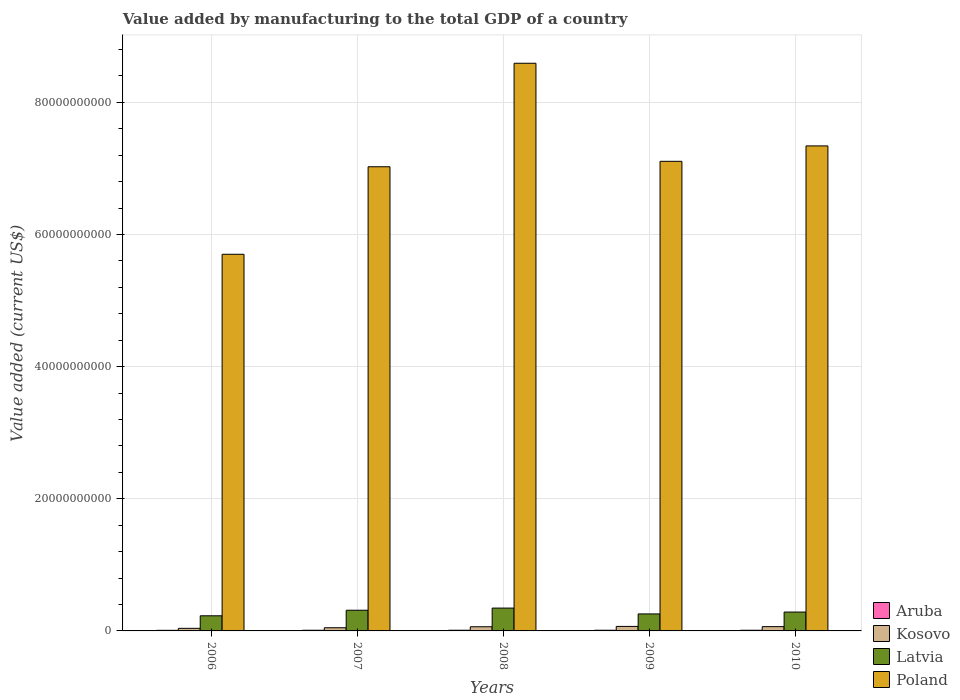How many different coloured bars are there?
Offer a very short reply. 4. How many groups of bars are there?
Offer a terse response. 5. Are the number of bars per tick equal to the number of legend labels?
Offer a very short reply. Yes. Are the number of bars on each tick of the X-axis equal?
Give a very brief answer. Yes. What is the label of the 3rd group of bars from the left?
Give a very brief answer. 2008. In how many cases, is the number of bars for a given year not equal to the number of legend labels?
Provide a short and direct response. 0. What is the value added by manufacturing to the total GDP in Latvia in 2010?
Give a very brief answer. 2.86e+09. Across all years, what is the maximum value added by manufacturing to the total GDP in Kosovo?
Give a very brief answer. 6.82e+08. Across all years, what is the minimum value added by manufacturing to the total GDP in Poland?
Ensure brevity in your answer.  5.70e+1. What is the total value added by manufacturing to the total GDP in Latvia in the graph?
Ensure brevity in your answer.  1.43e+1. What is the difference between the value added by manufacturing to the total GDP in Kosovo in 2009 and that in 2010?
Your response must be concise. 3.44e+07. What is the difference between the value added by manufacturing to the total GDP in Latvia in 2010 and the value added by manufacturing to the total GDP in Aruba in 2006?
Provide a succinct answer. 2.76e+09. What is the average value added by manufacturing to the total GDP in Aruba per year?
Your response must be concise. 9.95e+07. In the year 2008, what is the difference between the value added by manufacturing to the total GDP in Poland and value added by manufacturing to the total GDP in Latvia?
Your answer should be compact. 8.25e+1. What is the ratio of the value added by manufacturing to the total GDP in Aruba in 2009 to that in 2010?
Provide a short and direct response. 1.01. Is the value added by manufacturing to the total GDP in Poland in 2009 less than that in 2010?
Keep it short and to the point. Yes. Is the difference between the value added by manufacturing to the total GDP in Poland in 2007 and 2009 greater than the difference between the value added by manufacturing to the total GDP in Latvia in 2007 and 2009?
Ensure brevity in your answer.  No. What is the difference between the highest and the second highest value added by manufacturing to the total GDP in Kosovo?
Make the answer very short. 3.44e+07. What is the difference between the highest and the lowest value added by manufacturing to the total GDP in Latvia?
Make the answer very short. 1.17e+09. Is the sum of the value added by manufacturing to the total GDP in Poland in 2007 and 2008 greater than the maximum value added by manufacturing to the total GDP in Kosovo across all years?
Your answer should be compact. Yes. Is it the case that in every year, the sum of the value added by manufacturing to the total GDP in Aruba and value added by manufacturing to the total GDP in Latvia is greater than the sum of value added by manufacturing to the total GDP in Poland and value added by manufacturing to the total GDP in Kosovo?
Provide a short and direct response. No. What does the 4th bar from the left in 2007 represents?
Your answer should be very brief. Poland. What does the 4th bar from the right in 2008 represents?
Make the answer very short. Aruba. How many bars are there?
Give a very brief answer. 20. Are the values on the major ticks of Y-axis written in scientific E-notation?
Offer a very short reply. No. Does the graph contain any zero values?
Provide a succinct answer. No. Does the graph contain grids?
Ensure brevity in your answer.  Yes. Where does the legend appear in the graph?
Keep it short and to the point. Bottom right. What is the title of the graph?
Your answer should be very brief. Value added by manufacturing to the total GDP of a country. Does "Guyana" appear as one of the legend labels in the graph?
Give a very brief answer. No. What is the label or title of the Y-axis?
Offer a terse response. Value added (current US$). What is the Value added (current US$) of Aruba in 2006?
Offer a terse response. 9.12e+07. What is the Value added (current US$) in Kosovo in 2006?
Keep it short and to the point. 3.90e+08. What is the Value added (current US$) in Latvia in 2006?
Offer a very short reply. 2.29e+09. What is the Value added (current US$) in Poland in 2006?
Your answer should be compact. 5.70e+1. What is the Value added (current US$) of Aruba in 2007?
Give a very brief answer. 1.01e+08. What is the Value added (current US$) of Kosovo in 2007?
Your answer should be compact. 4.82e+08. What is the Value added (current US$) of Latvia in 2007?
Your answer should be very brief. 3.13e+09. What is the Value added (current US$) of Poland in 2007?
Provide a short and direct response. 7.03e+1. What is the Value added (current US$) of Aruba in 2008?
Provide a succinct answer. 1.02e+08. What is the Value added (current US$) of Kosovo in 2008?
Give a very brief answer. 6.29e+08. What is the Value added (current US$) of Latvia in 2008?
Your response must be concise. 3.46e+09. What is the Value added (current US$) in Poland in 2008?
Make the answer very short. 8.59e+1. What is the Value added (current US$) of Aruba in 2009?
Provide a short and direct response. 1.02e+08. What is the Value added (current US$) in Kosovo in 2009?
Your response must be concise. 6.82e+08. What is the Value added (current US$) in Latvia in 2009?
Your response must be concise. 2.57e+09. What is the Value added (current US$) in Poland in 2009?
Offer a terse response. 7.11e+1. What is the Value added (current US$) of Aruba in 2010?
Offer a terse response. 1.01e+08. What is the Value added (current US$) in Kosovo in 2010?
Keep it short and to the point. 6.48e+08. What is the Value added (current US$) in Latvia in 2010?
Your answer should be very brief. 2.86e+09. What is the Value added (current US$) of Poland in 2010?
Your response must be concise. 7.34e+1. Across all years, what is the maximum Value added (current US$) in Aruba?
Provide a short and direct response. 1.02e+08. Across all years, what is the maximum Value added (current US$) in Kosovo?
Offer a very short reply. 6.82e+08. Across all years, what is the maximum Value added (current US$) in Latvia?
Make the answer very short. 3.46e+09. Across all years, what is the maximum Value added (current US$) in Poland?
Your answer should be compact. 8.59e+1. Across all years, what is the minimum Value added (current US$) in Aruba?
Give a very brief answer. 9.12e+07. Across all years, what is the minimum Value added (current US$) of Kosovo?
Your response must be concise. 3.90e+08. Across all years, what is the minimum Value added (current US$) of Latvia?
Your answer should be very brief. 2.29e+09. Across all years, what is the minimum Value added (current US$) in Poland?
Offer a very short reply. 5.70e+1. What is the total Value added (current US$) of Aruba in the graph?
Your answer should be very brief. 4.97e+08. What is the total Value added (current US$) in Kosovo in the graph?
Offer a very short reply. 2.83e+09. What is the total Value added (current US$) of Latvia in the graph?
Provide a succinct answer. 1.43e+1. What is the total Value added (current US$) in Poland in the graph?
Give a very brief answer. 3.58e+11. What is the difference between the Value added (current US$) in Aruba in 2006 and that in 2007?
Provide a succinct answer. -9.60e+06. What is the difference between the Value added (current US$) in Kosovo in 2006 and that in 2007?
Give a very brief answer. -9.16e+07. What is the difference between the Value added (current US$) of Latvia in 2006 and that in 2007?
Offer a terse response. -8.42e+08. What is the difference between the Value added (current US$) of Poland in 2006 and that in 2007?
Offer a terse response. -1.32e+1. What is the difference between the Value added (current US$) of Aruba in 2006 and that in 2008?
Make the answer very short. -1.07e+07. What is the difference between the Value added (current US$) in Kosovo in 2006 and that in 2008?
Your answer should be compact. -2.39e+08. What is the difference between the Value added (current US$) in Latvia in 2006 and that in 2008?
Your answer should be very brief. -1.17e+09. What is the difference between the Value added (current US$) in Poland in 2006 and that in 2008?
Give a very brief answer. -2.89e+1. What is the difference between the Value added (current US$) of Aruba in 2006 and that in 2009?
Make the answer very short. -1.10e+07. What is the difference between the Value added (current US$) of Kosovo in 2006 and that in 2009?
Keep it short and to the point. -2.92e+08. What is the difference between the Value added (current US$) of Latvia in 2006 and that in 2009?
Offer a very short reply. -2.83e+08. What is the difference between the Value added (current US$) of Poland in 2006 and that in 2009?
Give a very brief answer. -1.41e+1. What is the difference between the Value added (current US$) in Aruba in 2006 and that in 2010?
Your response must be concise. -1.00e+07. What is the difference between the Value added (current US$) in Kosovo in 2006 and that in 2010?
Make the answer very short. -2.58e+08. What is the difference between the Value added (current US$) of Latvia in 2006 and that in 2010?
Ensure brevity in your answer.  -5.66e+08. What is the difference between the Value added (current US$) of Poland in 2006 and that in 2010?
Provide a succinct answer. -1.64e+1. What is the difference between the Value added (current US$) in Aruba in 2007 and that in 2008?
Provide a short and direct response. -1.11e+06. What is the difference between the Value added (current US$) in Kosovo in 2007 and that in 2008?
Offer a terse response. -1.47e+08. What is the difference between the Value added (current US$) in Latvia in 2007 and that in 2008?
Your answer should be compact. -3.26e+08. What is the difference between the Value added (current US$) of Poland in 2007 and that in 2008?
Provide a short and direct response. -1.57e+1. What is the difference between the Value added (current US$) of Aruba in 2007 and that in 2009?
Provide a short and direct response. -1.44e+06. What is the difference between the Value added (current US$) of Kosovo in 2007 and that in 2009?
Make the answer very short. -2.01e+08. What is the difference between the Value added (current US$) of Latvia in 2007 and that in 2009?
Provide a succinct answer. 5.58e+08. What is the difference between the Value added (current US$) of Poland in 2007 and that in 2009?
Give a very brief answer. -8.25e+08. What is the difference between the Value added (current US$) in Aruba in 2007 and that in 2010?
Ensure brevity in your answer.  -4.08e+05. What is the difference between the Value added (current US$) of Kosovo in 2007 and that in 2010?
Provide a succinct answer. -1.66e+08. What is the difference between the Value added (current US$) of Latvia in 2007 and that in 2010?
Provide a short and direct response. 2.75e+08. What is the difference between the Value added (current US$) of Poland in 2007 and that in 2010?
Make the answer very short. -3.16e+09. What is the difference between the Value added (current US$) in Aruba in 2008 and that in 2009?
Give a very brief answer. -3.30e+05. What is the difference between the Value added (current US$) of Kosovo in 2008 and that in 2009?
Offer a terse response. -5.33e+07. What is the difference between the Value added (current US$) in Latvia in 2008 and that in 2009?
Give a very brief answer. 8.85e+08. What is the difference between the Value added (current US$) in Poland in 2008 and that in 2009?
Offer a terse response. 1.48e+1. What is the difference between the Value added (current US$) in Aruba in 2008 and that in 2010?
Offer a very short reply. 7.04e+05. What is the difference between the Value added (current US$) of Kosovo in 2008 and that in 2010?
Make the answer very short. -1.89e+07. What is the difference between the Value added (current US$) in Latvia in 2008 and that in 2010?
Keep it short and to the point. 6.01e+08. What is the difference between the Value added (current US$) of Poland in 2008 and that in 2010?
Ensure brevity in your answer.  1.25e+1. What is the difference between the Value added (current US$) of Aruba in 2009 and that in 2010?
Ensure brevity in your answer.  1.03e+06. What is the difference between the Value added (current US$) in Kosovo in 2009 and that in 2010?
Keep it short and to the point. 3.44e+07. What is the difference between the Value added (current US$) in Latvia in 2009 and that in 2010?
Ensure brevity in your answer.  -2.83e+08. What is the difference between the Value added (current US$) in Poland in 2009 and that in 2010?
Offer a very short reply. -2.33e+09. What is the difference between the Value added (current US$) in Aruba in 2006 and the Value added (current US$) in Kosovo in 2007?
Offer a very short reply. -3.91e+08. What is the difference between the Value added (current US$) of Aruba in 2006 and the Value added (current US$) of Latvia in 2007?
Provide a succinct answer. -3.04e+09. What is the difference between the Value added (current US$) in Aruba in 2006 and the Value added (current US$) in Poland in 2007?
Offer a very short reply. -7.02e+1. What is the difference between the Value added (current US$) of Kosovo in 2006 and the Value added (current US$) of Latvia in 2007?
Your answer should be compact. -2.74e+09. What is the difference between the Value added (current US$) in Kosovo in 2006 and the Value added (current US$) in Poland in 2007?
Offer a terse response. -6.99e+1. What is the difference between the Value added (current US$) of Latvia in 2006 and the Value added (current US$) of Poland in 2007?
Your response must be concise. -6.80e+1. What is the difference between the Value added (current US$) of Aruba in 2006 and the Value added (current US$) of Kosovo in 2008?
Give a very brief answer. -5.38e+08. What is the difference between the Value added (current US$) of Aruba in 2006 and the Value added (current US$) of Latvia in 2008?
Make the answer very short. -3.37e+09. What is the difference between the Value added (current US$) of Aruba in 2006 and the Value added (current US$) of Poland in 2008?
Provide a succinct answer. -8.58e+1. What is the difference between the Value added (current US$) of Kosovo in 2006 and the Value added (current US$) of Latvia in 2008?
Your answer should be compact. -3.07e+09. What is the difference between the Value added (current US$) of Kosovo in 2006 and the Value added (current US$) of Poland in 2008?
Offer a very short reply. -8.55e+1. What is the difference between the Value added (current US$) in Latvia in 2006 and the Value added (current US$) in Poland in 2008?
Your response must be concise. -8.36e+1. What is the difference between the Value added (current US$) of Aruba in 2006 and the Value added (current US$) of Kosovo in 2009?
Ensure brevity in your answer.  -5.91e+08. What is the difference between the Value added (current US$) in Aruba in 2006 and the Value added (current US$) in Latvia in 2009?
Keep it short and to the point. -2.48e+09. What is the difference between the Value added (current US$) in Aruba in 2006 and the Value added (current US$) in Poland in 2009?
Make the answer very short. -7.10e+1. What is the difference between the Value added (current US$) in Kosovo in 2006 and the Value added (current US$) in Latvia in 2009?
Give a very brief answer. -2.18e+09. What is the difference between the Value added (current US$) of Kosovo in 2006 and the Value added (current US$) of Poland in 2009?
Your answer should be very brief. -7.07e+1. What is the difference between the Value added (current US$) of Latvia in 2006 and the Value added (current US$) of Poland in 2009?
Your answer should be compact. -6.88e+1. What is the difference between the Value added (current US$) in Aruba in 2006 and the Value added (current US$) in Kosovo in 2010?
Keep it short and to the point. -5.57e+08. What is the difference between the Value added (current US$) in Aruba in 2006 and the Value added (current US$) in Latvia in 2010?
Offer a very short reply. -2.76e+09. What is the difference between the Value added (current US$) in Aruba in 2006 and the Value added (current US$) in Poland in 2010?
Ensure brevity in your answer.  -7.33e+1. What is the difference between the Value added (current US$) of Kosovo in 2006 and the Value added (current US$) of Latvia in 2010?
Offer a terse response. -2.47e+09. What is the difference between the Value added (current US$) in Kosovo in 2006 and the Value added (current US$) in Poland in 2010?
Keep it short and to the point. -7.30e+1. What is the difference between the Value added (current US$) in Latvia in 2006 and the Value added (current US$) in Poland in 2010?
Provide a short and direct response. -7.11e+1. What is the difference between the Value added (current US$) in Aruba in 2007 and the Value added (current US$) in Kosovo in 2008?
Offer a very short reply. -5.28e+08. What is the difference between the Value added (current US$) in Aruba in 2007 and the Value added (current US$) in Latvia in 2008?
Provide a succinct answer. -3.36e+09. What is the difference between the Value added (current US$) in Aruba in 2007 and the Value added (current US$) in Poland in 2008?
Offer a terse response. -8.58e+1. What is the difference between the Value added (current US$) in Kosovo in 2007 and the Value added (current US$) in Latvia in 2008?
Ensure brevity in your answer.  -2.98e+09. What is the difference between the Value added (current US$) of Kosovo in 2007 and the Value added (current US$) of Poland in 2008?
Provide a succinct answer. -8.54e+1. What is the difference between the Value added (current US$) of Latvia in 2007 and the Value added (current US$) of Poland in 2008?
Give a very brief answer. -8.28e+1. What is the difference between the Value added (current US$) of Aruba in 2007 and the Value added (current US$) of Kosovo in 2009?
Offer a very short reply. -5.82e+08. What is the difference between the Value added (current US$) in Aruba in 2007 and the Value added (current US$) in Latvia in 2009?
Provide a succinct answer. -2.47e+09. What is the difference between the Value added (current US$) of Aruba in 2007 and the Value added (current US$) of Poland in 2009?
Make the answer very short. -7.10e+1. What is the difference between the Value added (current US$) in Kosovo in 2007 and the Value added (current US$) in Latvia in 2009?
Keep it short and to the point. -2.09e+09. What is the difference between the Value added (current US$) of Kosovo in 2007 and the Value added (current US$) of Poland in 2009?
Provide a succinct answer. -7.06e+1. What is the difference between the Value added (current US$) in Latvia in 2007 and the Value added (current US$) in Poland in 2009?
Ensure brevity in your answer.  -6.79e+1. What is the difference between the Value added (current US$) of Aruba in 2007 and the Value added (current US$) of Kosovo in 2010?
Your answer should be very brief. -5.47e+08. What is the difference between the Value added (current US$) of Aruba in 2007 and the Value added (current US$) of Latvia in 2010?
Give a very brief answer. -2.76e+09. What is the difference between the Value added (current US$) in Aruba in 2007 and the Value added (current US$) in Poland in 2010?
Provide a succinct answer. -7.33e+1. What is the difference between the Value added (current US$) of Kosovo in 2007 and the Value added (current US$) of Latvia in 2010?
Offer a very short reply. -2.37e+09. What is the difference between the Value added (current US$) in Kosovo in 2007 and the Value added (current US$) in Poland in 2010?
Offer a very short reply. -7.29e+1. What is the difference between the Value added (current US$) in Latvia in 2007 and the Value added (current US$) in Poland in 2010?
Keep it short and to the point. -7.03e+1. What is the difference between the Value added (current US$) of Aruba in 2008 and the Value added (current US$) of Kosovo in 2009?
Make the answer very short. -5.81e+08. What is the difference between the Value added (current US$) in Aruba in 2008 and the Value added (current US$) in Latvia in 2009?
Ensure brevity in your answer.  -2.47e+09. What is the difference between the Value added (current US$) of Aruba in 2008 and the Value added (current US$) of Poland in 2009?
Give a very brief answer. -7.10e+1. What is the difference between the Value added (current US$) in Kosovo in 2008 and the Value added (current US$) in Latvia in 2009?
Your answer should be very brief. -1.94e+09. What is the difference between the Value added (current US$) in Kosovo in 2008 and the Value added (current US$) in Poland in 2009?
Provide a succinct answer. -7.05e+1. What is the difference between the Value added (current US$) in Latvia in 2008 and the Value added (current US$) in Poland in 2009?
Provide a succinct answer. -6.76e+1. What is the difference between the Value added (current US$) in Aruba in 2008 and the Value added (current US$) in Kosovo in 2010?
Your response must be concise. -5.46e+08. What is the difference between the Value added (current US$) of Aruba in 2008 and the Value added (current US$) of Latvia in 2010?
Keep it short and to the point. -2.75e+09. What is the difference between the Value added (current US$) of Aruba in 2008 and the Value added (current US$) of Poland in 2010?
Provide a short and direct response. -7.33e+1. What is the difference between the Value added (current US$) in Kosovo in 2008 and the Value added (current US$) in Latvia in 2010?
Your answer should be very brief. -2.23e+09. What is the difference between the Value added (current US$) in Kosovo in 2008 and the Value added (current US$) in Poland in 2010?
Make the answer very short. -7.28e+1. What is the difference between the Value added (current US$) of Latvia in 2008 and the Value added (current US$) of Poland in 2010?
Make the answer very short. -7.00e+1. What is the difference between the Value added (current US$) of Aruba in 2009 and the Value added (current US$) of Kosovo in 2010?
Ensure brevity in your answer.  -5.46e+08. What is the difference between the Value added (current US$) in Aruba in 2009 and the Value added (current US$) in Latvia in 2010?
Ensure brevity in your answer.  -2.75e+09. What is the difference between the Value added (current US$) of Aruba in 2009 and the Value added (current US$) of Poland in 2010?
Your response must be concise. -7.33e+1. What is the difference between the Value added (current US$) in Kosovo in 2009 and the Value added (current US$) in Latvia in 2010?
Your answer should be very brief. -2.17e+09. What is the difference between the Value added (current US$) in Kosovo in 2009 and the Value added (current US$) in Poland in 2010?
Your answer should be very brief. -7.27e+1. What is the difference between the Value added (current US$) of Latvia in 2009 and the Value added (current US$) of Poland in 2010?
Offer a terse response. -7.08e+1. What is the average Value added (current US$) in Aruba per year?
Make the answer very short. 9.95e+07. What is the average Value added (current US$) in Kosovo per year?
Provide a succinct answer. 5.66e+08. What is the average Value added (current US$) of Latvia per year?
Give a very brief answer. 2.86e+09. What is the average Value added (current US$) in Poland per year?
Keep it short and to the point. 7.15e+1. In the year 2006, what is the difference between the Value added (current US$) in Aruba and Value added (current US$) in Kosovo?
Your response must be concise. -2.99e+08. In the year 2006, what is the difference between the Value added (current US$) in Aruba and Value added (current US$) in Latvia?
Offer a very short reply. -2.20e+09. In the year 2006, what is the difference between the Value added (current US$) in Aruba and Value added (current US$) in Poland?
Give a very brief answer. -5.69e+1. In the year 2006, what is the difference between the Value added (current US$) of Kosovo and Value added (current US$) of Latvia?
Make the answer very short. -1.90e+09. In the year 2006, what is the difference between the Value added (current US$) in Kosovo and Value added (current US$) in Poland?
Your answer should be very brief. -5.66e+1. In the year 2006, what is the difference between the Value added (current US$) of Latvia and Value added (current US$) of Poland?
Provide a short and direct response. -5.47e+1. In the year 2007, what is the difference between the Value added (current US$) in Aruba and Value added (current US$) in Kosovo?
Offer a terse response. -3.81e+08. In the year 2007, what is the difference between the Value added (current US$) of Aruba and Value added (current US$) of Latvia?
Ensure brevity in your answer.  -3.03e+09. In the year 2007, what is the difference between the Value added (current US$) of Aruba and Value added (current US$) of Poland?
Give a very brief answer. -7.02e+1. In the year 2007, what is the difference between the Value added (current US$) in Kosovo and Value added (current US$) in Latvia?
Your response must be concise. -2.65e+09. In the year 2007, what is the difference between the Value added (current US$) of Kosovo and Value added (current US$) of Poland?
Keep it short and to the point. -6.98e+1. In the year 2007, what is the difference between the Value added (current US$) of Latvia and Value added (current US$) of Poland?
Give a very brief answer. -6.71e+1. In the year 2008, what is the difference between the Value added (current US$) in Aruba and Value added (current US$) in Kosovo?
Your answer should be very brief. -5.27e+08. In the year 2008, what is the difference between the Value added (current US$) in Aruba and Value added (current US$) in Latvia?
Offer a very short reply. -3.36e+09. In the year 2008, what is the difference between the Value added (current US$) of Aruba and Value added (current US$) of Poland?
Keep it short and to the point. -8.58e+1. In the year 2008, what is the difference between the Value added (current US$) of Kosovo and Value added (current US$) of Latvia?
Ensure brevity in your answer.  -2.83e+09. In the year 2008, what is the difference between the Value added (current US$) in Kosovo and Value added (current US$) in Poland?
Keep it short and to the point. -8.53e+1. In the year 2008, what is the difference between the Value added (current US$) in Latvia and Value added (current US$) in Poland?
Provide a short and direct response. -8.25e+1. In the year 2009, what is the difference between the Value added (current US$) of Aruba and Value added (current US$) of Kosovo?
Your answer should be very brief. -5.80e+08. In the year 2009, what is the difference between the Value added (current US$) of Aruba and Value added (current US$) of Latvia?
Keep it short and to the point. -2.47e+09. In the year 2009, what is the difference between the Value added (current US$) in Aruba and Value added (current US$) in Poland?
Your response must be concise. -7.10e+1. In the year 2009, what is the difference between the Value added (current US$) in Kosovo and Value added (current US$) in Latvia?
Provide a short and direct response. -1.89e+09. In the year 2009, what is the difference between the Value added (current US$) in Kosovo and Value added (current US$) in Poland?
Keep it short and to the point. -7.04e+1. In the year 2009, what is the difference between the Value added (current US$) of Latvia and Value added (current US$) of Poland?
Your answer should be compact. -6.85e+1. In the year 2010, what is the difference between the Value added (current US$) of Aruba and Value added (current US$) of Kosovo?
Offer a terse response. -5.47e+08. In the year 2010, what is the difference between the Value added (current US$) of Aruba and Value added (current US$) of Latvia?
Make the answer very short. -2.75e+09. In the year 2010, what is the difference between the Value added (current US$) of Aruba and Value added (current US$) of Poland?
Your answer should be compact. -7.33e+1. In the year 2010, what is the difference between the Value added (current US$) of Kosovo and Value added (current US$) of Latvia?
Your answer should be very brief. -2.21e+09. In the year 2010, what is the difference between the Value added (current US$) of Kosovo and Value added (current US$) of Poland?
Offer a very short reply. -7.28e+1. In the year 2010, what is the difference between the Value added (current US$) in Latvia and Value added (current US$) in Poland?
Make the answer very short. -7.06e+1. What is the ratio of the Value added (current US$) of Aruba in 2006 to that in 2007?
Make the answer very short. 0.9. What is the ratio of the Value added (current US$) in Kosovo in 2006 to that in 2007?
Give a very brief answer. 0.81. What is the ratio of the Value added (current US$) of Latvia in 2006 to that in 2007?
Provide a succinct answer. 0.73. What is the ratio of the Value added (current US$) of Poland in 2006 to that in 2007?
Provide a short and direct response. 0.81. What is the ratio of the Value added (current US$) in Aruba in 2006 to that in 2008?
Offer a terse response. 0.89. What is the ratio of the Value added (current US$) in Kosovo in 2006 to that in 2008?
Your answer should be very brief. 0.62. What is the ratio of the Value added (current US$) in Latvia in 2006 to that in 2008?
Your answer should be very brief. 0.66. What is the ratio of the Value added (current US$) in Poland in 2006 to that in 2008?
Your answer should be compact. 0.66. What is the ratio of the Value added (current US$) in Aruba in 2006 to that in 2009?
Your answer should be compact. 0.89. What is the ratio of the Value added (current US$) in Kosovo in 2006 to that in 2009?
Your answer should be compact. 0.57. What is the ratio of the Value added (current US$) of Latvia in 2006 to that in 2009?
Ensure brevity in your answer.  0.89. What is the ratio of the Value added (current US$) in Poland in 2006 to that in 2009?
Provide a short and direct response. 0.8. What is the ratio of the Value added (current US$) in Aruba in 2006 to that in 2010?
Your response must be concise. 0.9. What is the ratio of the Value added (current US$) in Kosovo in 2006 to that in 2010?
Your response must be concise. 0.6. What is the ratio of the Value added (current US$) of Latvia in 2006 to that in 2010?
Make the answer very short. 0.8. What is the ratio of the Value added (current US$) in Poland in 2006 to that in 2010?
Offer a very short reply. 0.78. What is the ratio of the Value added (current US$) in Aruba in 2007 to that in 2008?
Give a very brief answer. 0.99. What is the ratio of the Value added (current US$) of Kosovo in 2007 to that in 2008?
Keep it short and to the point. 0.77. What is the ratio of the Value added (current US$) in Latvia in 2007 to that in 2008?
Ensure brevity in your answer.  0.91. What is the ratio of the Value added (current US$) in Poland in 2007 to that in 2008?
Make the answer very short. 0.82. What is the ratio of the Value added (current US$) of Aruba in 2007 to that in 2009?
Provide a succinct answer. 0.99. What is the ratio of the Value added (current US$) in Kosovo in 2007 to that in 2009?
Your answer should be very brief. 0.71. What is the ratio of the Value added (current US$) of Latvia in 2007 to that in 2009?
Your response must be concise. 1.22. What is the ratio of the Value added (current US$) of Poland in 2007 to that in 2009?
Your answer should be very brief. 0.99. What is the ratio of the Value added (current US$) in Kosovo in 2007 to that in 2010?
Make the answer very short. 0.74. What is the ratio of the Value added (current US$) in Latvia in 2007 to that in 2010?
Ensure brevity in your answer.  1.1. What is the ratio of the Value added (current US$) in Poland in 2007 to that in 2010?
Make the answer very short. 0.96. What is the ratio of the Value added (current US$) of Kosovo in 2008 to that in 2009?
Make the answer very short. 0.92. What is the ratio of the Value added (current US$) in Latvia in 2008 to that in 2009?
Give a very brief answer. 1.34. What is the ratio of the Value added (current US$) in Poland in 2008 to that in 2009?
Your answer should be very brief. 1.21. What is the ratio of the Value added (current US$) of Kosovo in 2008 to that in 2010?
Your answer should be very brief. 0.97. What is the ratio of the Value added (current US$) of Latvia in 2008 to that in 2010?
Provide a succinct answer. 1.21. What is the ratio of the Value added (current US$) of Poland in 2008 to that in 2010?
Provide a succinct answer. 1.17. What is the ratio of the Value added (current US$) in Aruba in 2009 to that in 2010?
Your answer should be very brief. 1.01. What is the ratio of the Value added (current US$) of Kosovo in 2009 to that in 2010?
Your answer should be compact. 1.05. What is the ratio of the Value added (current US$) in Latvia in 2009 to that in 2010?
Provide a succinct answer. 0.9. What is the ratio of the Value added (current US$) in Poland in 2009 to that in 2010?
Keep it short and to the point. 0.97. What is the difference between the highest and the second highest Value added (current US$) in Aruba?
Offer a very short reply. 3.30e+05. What is the difference between the highest and the second highest Value added (current US$) in Kosovo?
Make the answer very short. 3.44e+07. What is the difference between the highest and the second highest Value added (current US$) of Latvia?
Ensure brevity in your answer.  3.26e+08. What is the difference between the highest and the second highest Value added (current US$) of Poland?
Give a very brief answer. 1.25e+1. What is the difference between the highest and the lowest Value added (current US$) of Aruba?
Your answer should be compact. 1.10e+07. What is the difference between the highest and the lowest Value added (current US$) of Kosovo?
Provide a short and direct response. 2.92e+08. What is the difference between the highest and the lowest Value added (current US$) in Latvia?
Offer a very short reply. 1.17e+09. What is the difference between the highest and the lowest Value added (current US$) of Poland?
Give a very brief answer. 2.89e+1. 